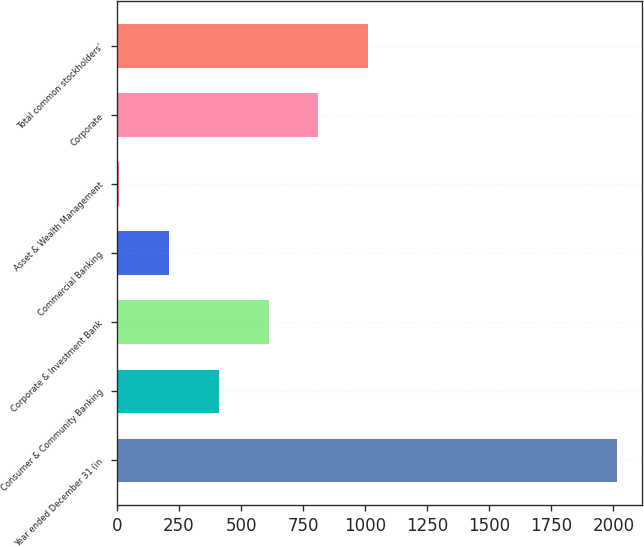Convert chart to OTSL. <chart><loc_0><loc_0><loc_500><loc_500><bar_chart><fcel>Year ended December 31 (in<fcel>Consumer & Community Banking<fcel>Corporate & Investment Bank<fcel>Commercial Banking<fcel>Asset & Wealth Management<fcel>Corporate<fcel>Total common stockholders'<nl><fcel>2016<fcel>410.4<fcel>611.1<fcel>209.7<fcel>9<fcel>811.8<fcel>1012.5<nl></chart> 